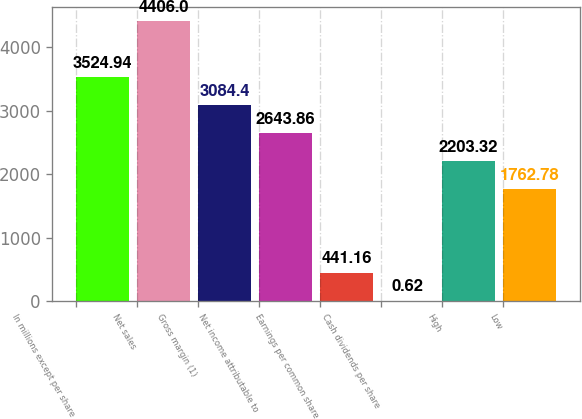Convert chart. <chart><loc_0><loc_0><loc_500><loc_500><bar_chart><fcel>In millions except per share<fcel>Net sales<fcel>Gross margin (1)<fcel>Net income attributable to<fcel>Earnings per common share<fcel>Cash dividends per share<fcel>High<fcel>Low<nl><fcel>3524.94<fcel>4406<fcel>3084.4<fcel>2643.86<fcel>441.16<fcel>0.62<fcel>2203.32<fcel>1762.78<nl></chart> 